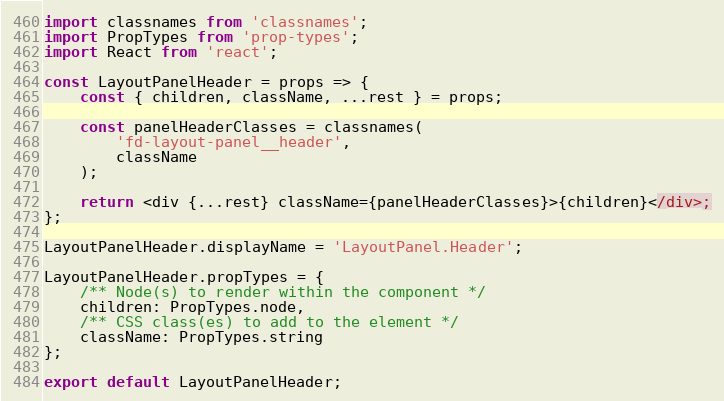Convert code to text. <code><loc_0><loc_0><loc_500><loc_500><_JavaScript_>import classnames from 'classnames';
import PropTypes from 'prop-types';
import React from 'react';

const LayoutPanelHeader = props => {
    const { children, className, ...rest } = props;

    const panelHeaderClasses = classnames(
        'fd-layout-panel__header',
        className
    );

    return <div {...rest} className={panelHeaderClasses}>{children}</div>;
};

LayoutPanelHeader.displayName = 'LayoutPanel.Header';

LayoutPanelHeader.propTypes = {
    /** Node(s) to render within the component */
    children: PropTypes.node,
    /** CSS class(es) to add to the element */
    className: PropTypes.string
};

export default LayoutPanelHeader;
</code> 